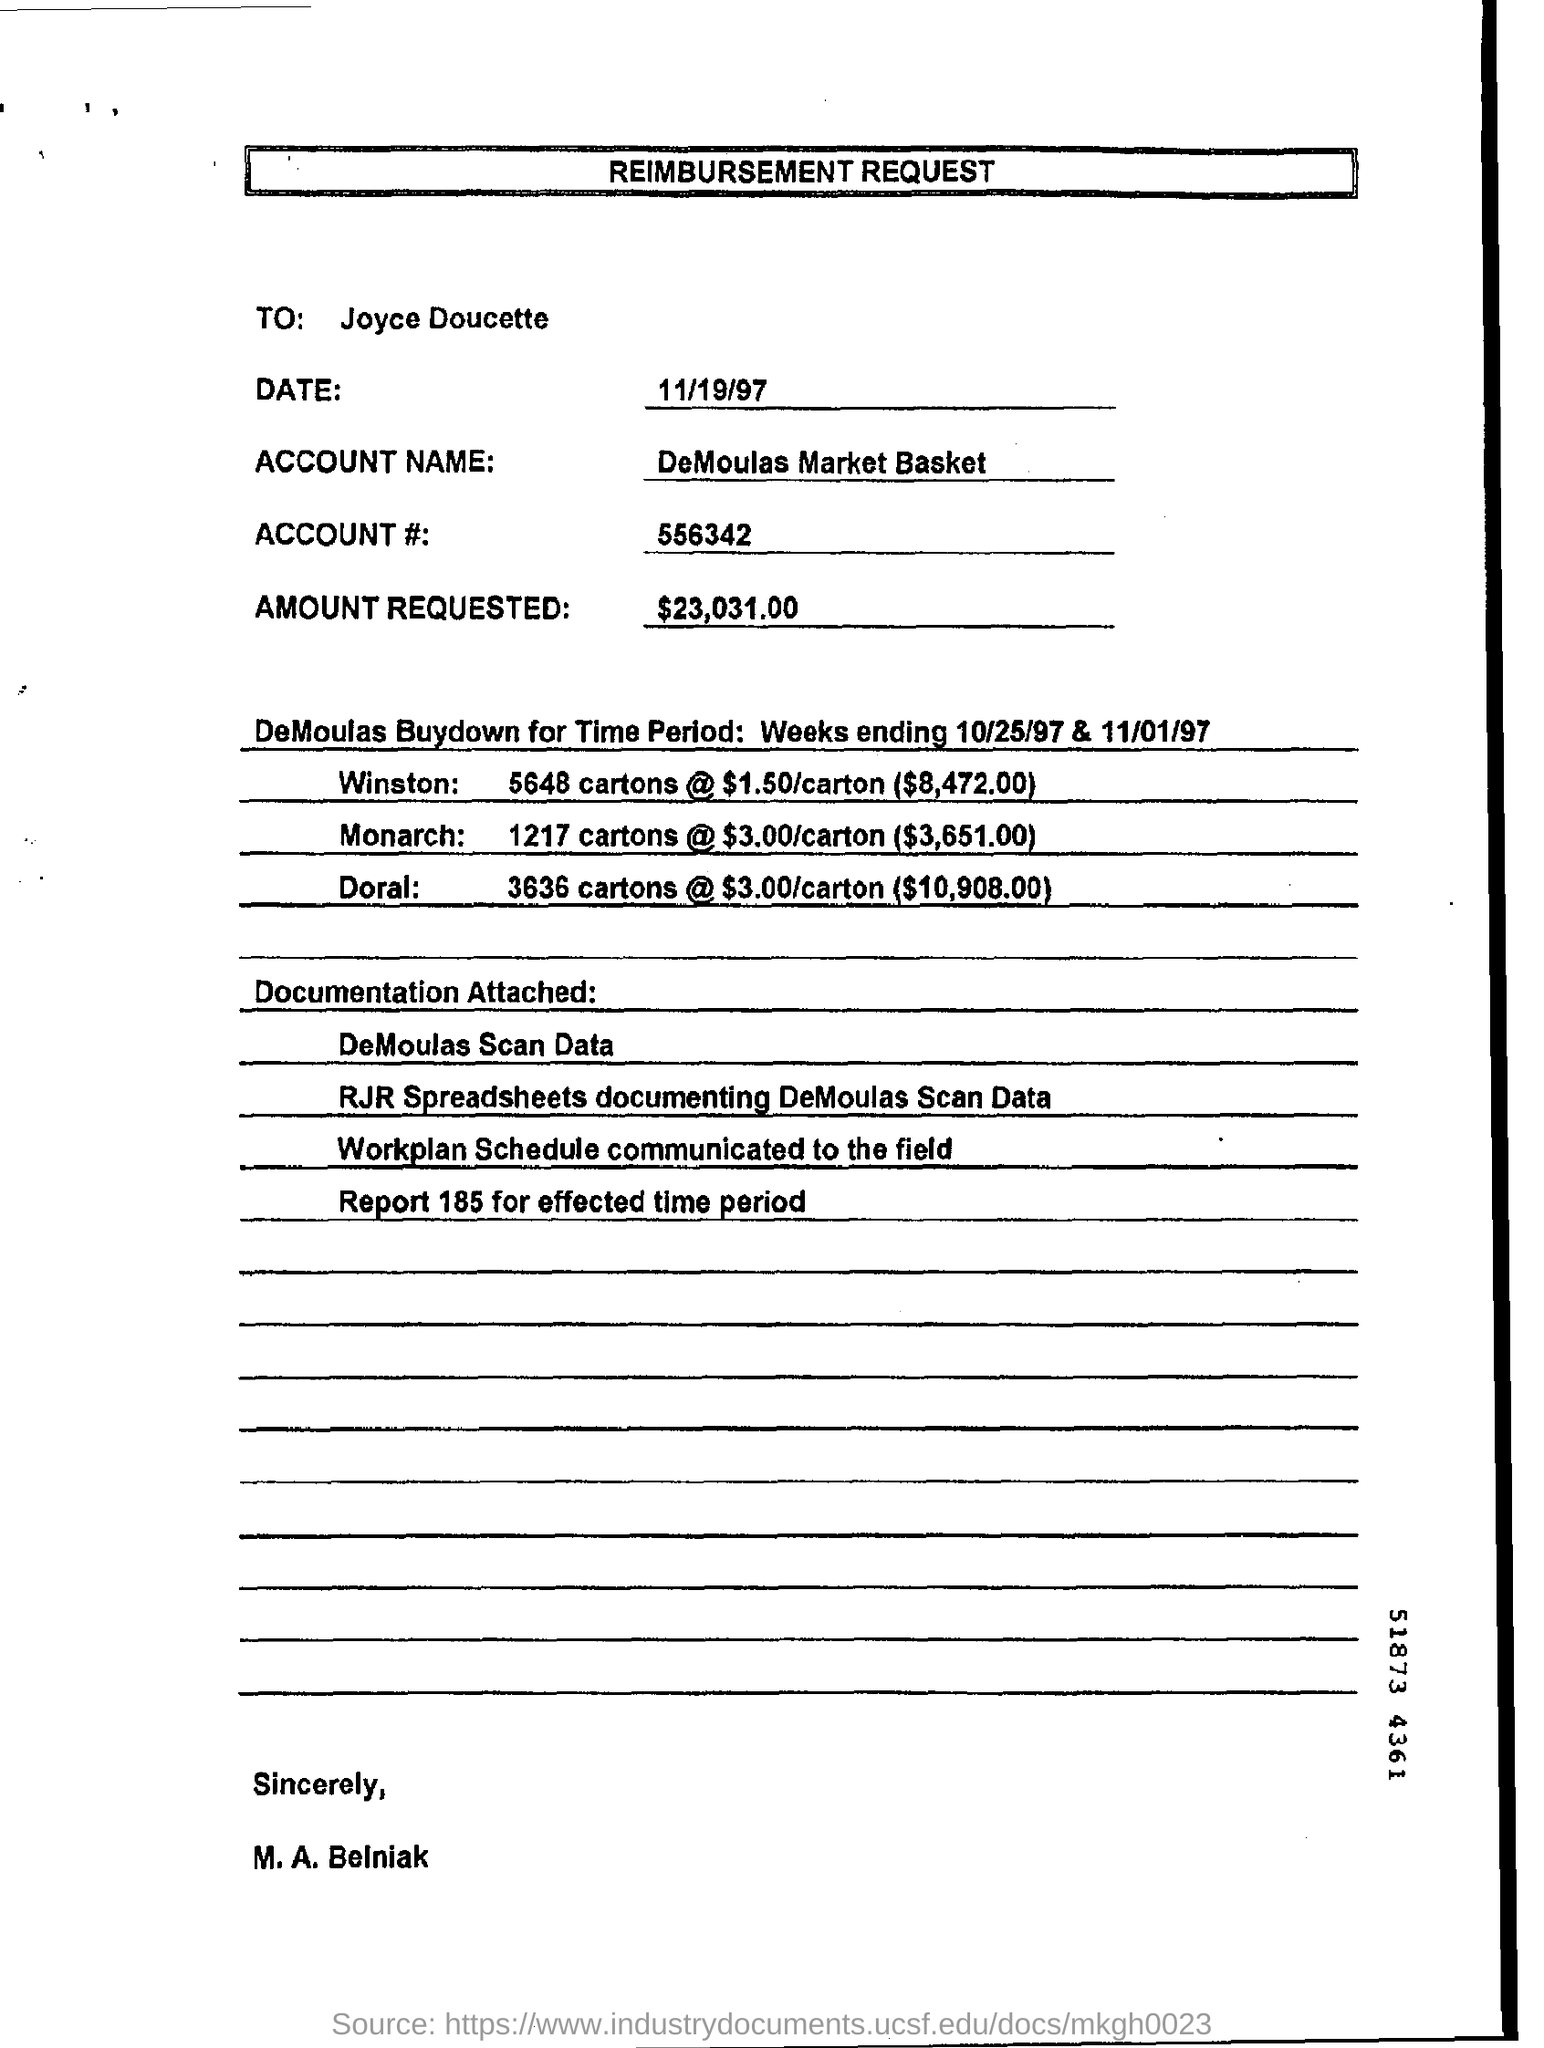What is the heading of the document?
Give a very brief answer. Reimbursement request. To whom is this document addressed?
Offer a very short reply. Joyce doucette. What is the date mentioned?
Your answer should be very brief. 11/19/97. What is the ACCOUNT NAME?
Provide a succinct answer. DeMoulas Market Basket. 